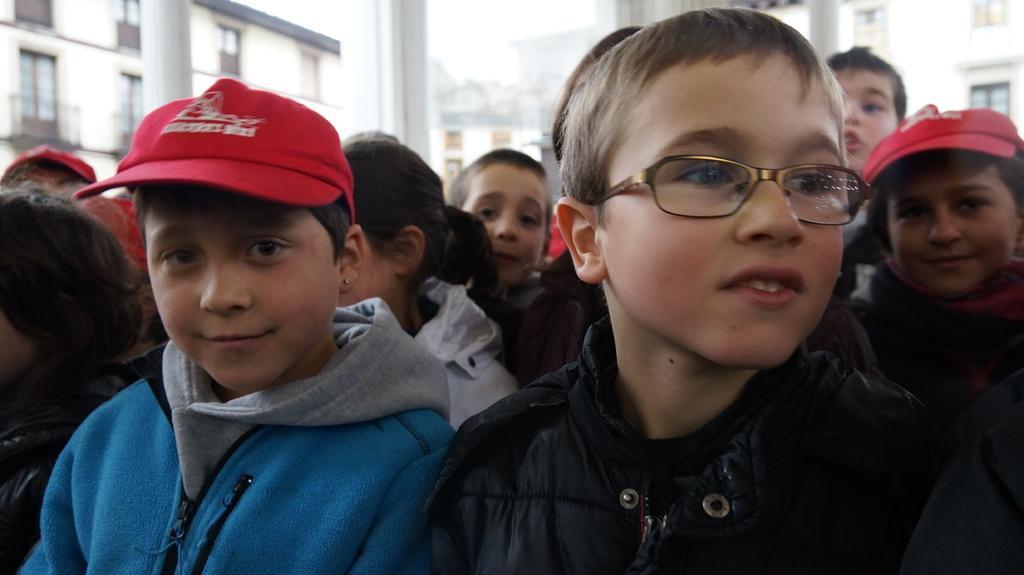Please provide a concise description of this image. In this image we can see a group of people, among them some are wearing caps, there are some buildings and poles, also we can see the sky. 